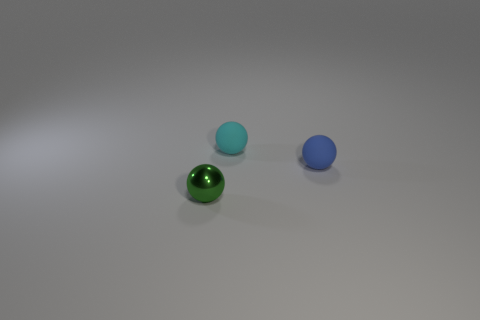There is a tiny ball to the right of the tiny cyan ball; is there a blue matte ball in front of it?
Offer a very short reply. No. Is the green object in front of the cyan object made of the same material as the blue thing?
Offer a terse response. No. How many tiny spheres are behind the tiny metal sphere and in front of the tiny cyan ball?
Offer a very short reply. 1. What number of other blue spheres have the same material as the blue ball?
Your answer should be very brief. 0. The other sphere that is made of the same material as the blue sphere is what color?
Provide a succinct answer. Cyan. Is the number of small rubber things less than the number of small green balls?
Provide a short and direct response. No. What material is the object that is to the right of the rubber sphere that is behind the small blue rubber sphere that is in front of the cyan matte ball made of?
Keep it short and to the point. Rubber. What is the material of the tiny cyan sphere?
Offer a very short reply. Rubber. Is the color of the sphere behind the tiny blue ball the same as the tiny sphere that is in front of the tiny blue rubber object?
Keep it short and to the point. No. Are there more tiny green metallic things than big blue metallic spheres?
Your answer should be compact. Yes. 